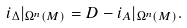Convert formula to latex. <formula><loc_0><loc_0><loc_500><loc_500>i _ { \Delta } | _ { \Omega ^ { n } ( M ) } = D - i _ { A } | _ { \Omega ^ { n } ( M ) } .</formula> 